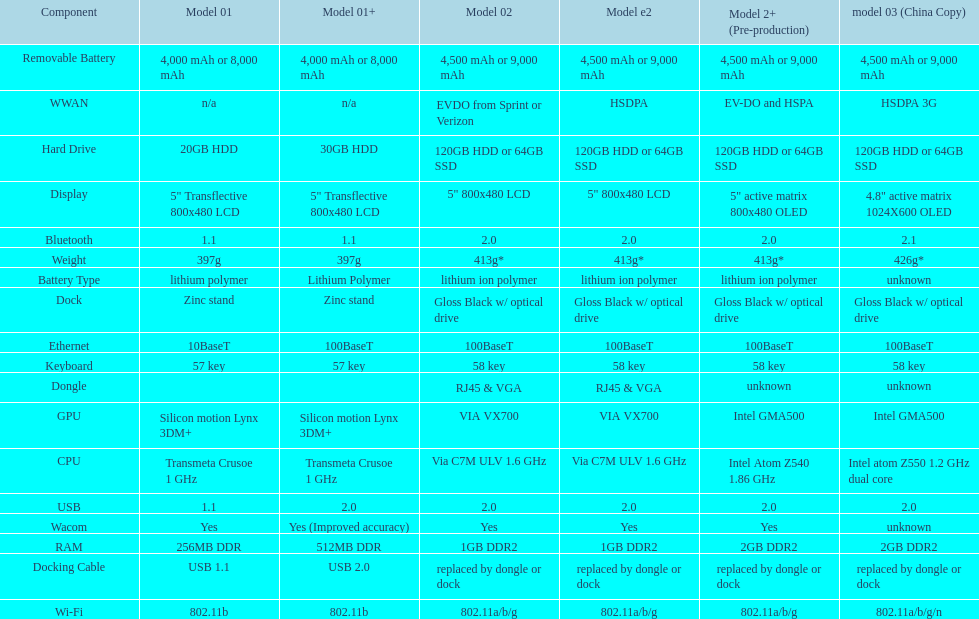Which model weighs the most, according to the table? Model 03 (china copy). 